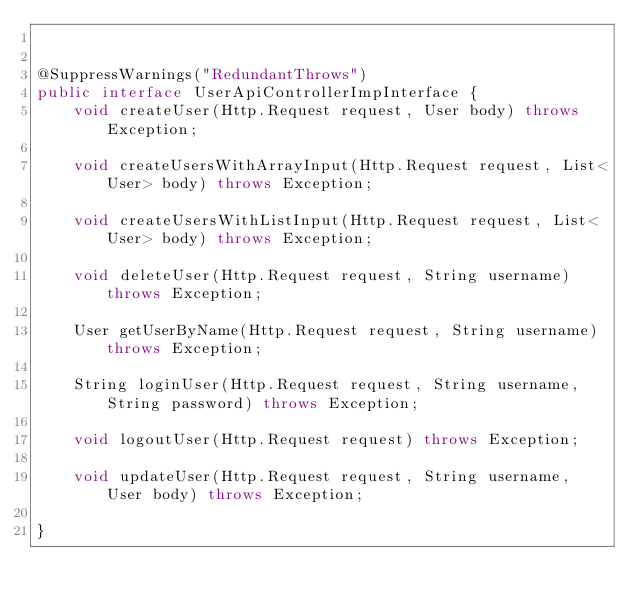Convert code to text. <code><loc_0><loc_0><loc_500><loc_500><_Java_>

@SuppressWarnings("RedundantThrows")
public interface UserApiControllerImpInterface {
    void createUser(Http.Request request, User body) throws Exception;

    void createUsersWithArrayInput(Http.Request request, List<User> body) throws Exception;

    void createUsersWithListInput(Http.Request request, List<User> body) throws Exception;

    void deleteUser(Http.Request request, String username) throws Exception;

    User getUserByName(Http.Request request, String username) throws Exception;

    String loginUser(Http.Request request, String username, String password) throws Exception;

    void logoutUser(Http.Request request) throws Exception;

    void updateUser(Http.Request request, String username, User body) throws Exception;

}
</code> 